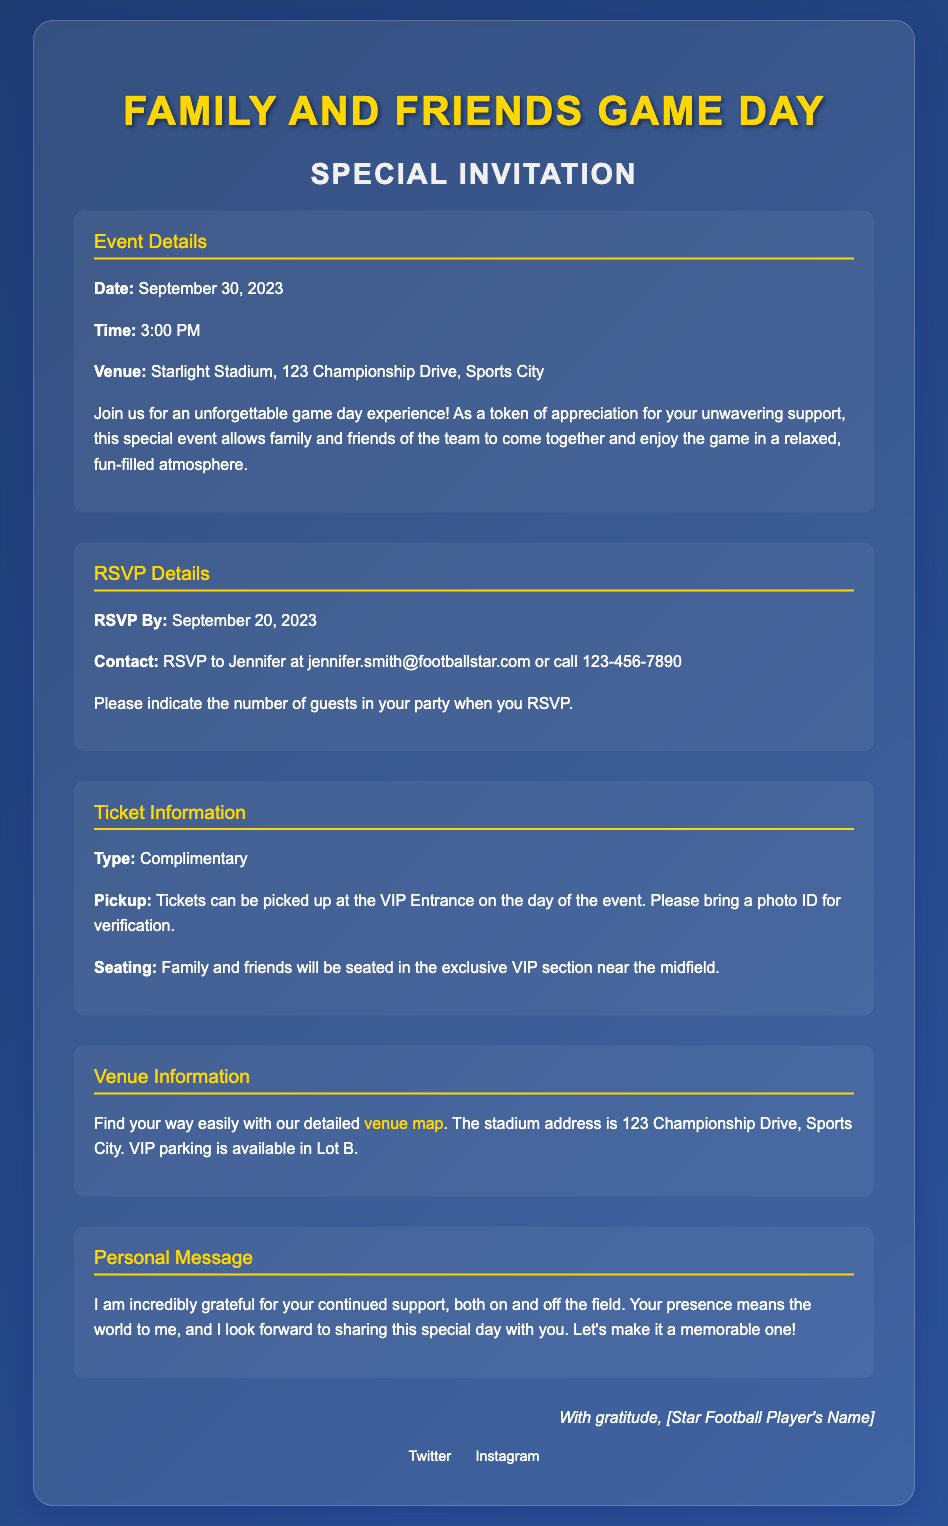What is the date of the event? The date of the event is specifically mentioned in the "Event Details" section.
Answer: September 30, 2023 Who should RSVPs be sent to? The RSVP details specify the contact person for RSVPs.
Answer: Jennifer What time does the game start? The time of the event is stated under the "Event Details" section.
Answer: 3:00 PM Where is the venue located? The venue information includes the specific address of the stadium.
Answer: Starlight Stadium, 123 Championship Drive, Sports City What type of tickets are being offered? The "Ticket Information" section indicates the type of tickets available for the event.
Answer: Complimentary How many guests should be indicated in the RSVP? The RSVP details encourage mentioning the number of guests accompanying the RSVP.
Answer: Number of guests What should be presented for ticket pickup? The "Ticket Information" section outlines what is required to pick up tickets.
Answer: Photo ID Why is the event being held? The personal message explains the purpose of the event and the appreciation behind it.
Answer: Appreciation for support Which section of the venue will family and friends be seated? The "Ticket Information" section details the seating arrangements for guests.
Answer: Exclusive VIP section near midfield 